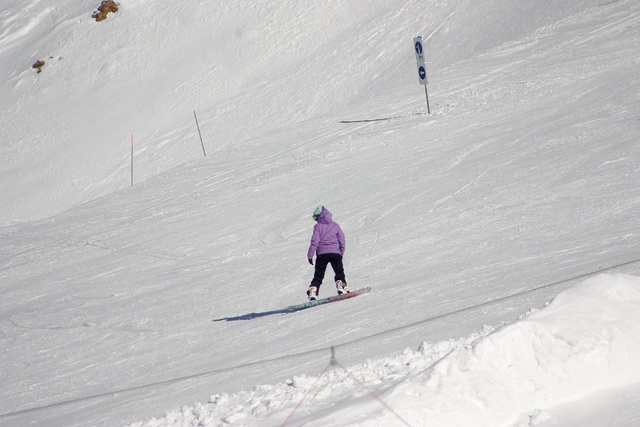Describe the objects in this image and their specific colors. I can see people in darkgray, violet, black, and purple tones and snowboard in darkgray, gray, and brown tones in this image. 